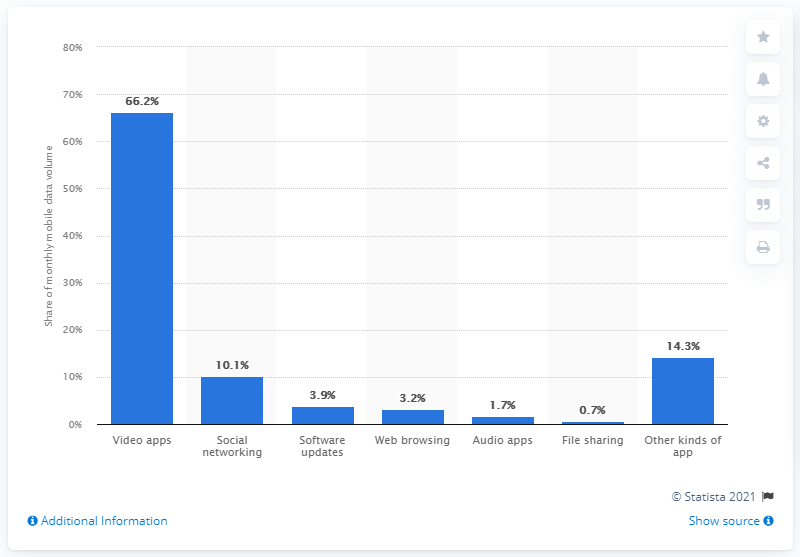Identify some key points in this picture. In January 2021, social networking accounted for approximately 10.1% of the total global mobile data volume. 